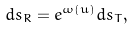<formula> <loc_0><loc_0><loc_500><loc_500>d s _ { R } = e ^ { \omega ( u ) } d s _ { T } ,</formula> 